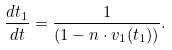<formula> <loc_0><loc_0><loc_500><loc_500>\frac { d t _ { 1 } } { d t } = \frac { 1 } { ( 1 - n \cdot v _ { 1 } ( t _ { 1 } ) ) } .</formula> 